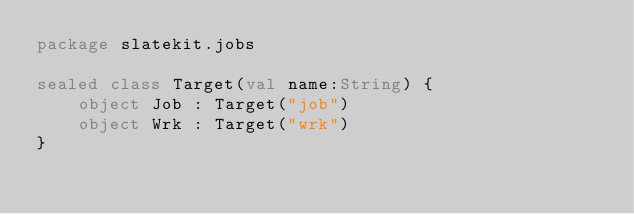<code> <loc_0><loc_0><loc_500><loc_500><_Kotlin_>package slatekit.jobs

sealed class Target(val name:String) {
    object Job : Target("job")
    object Wrk : Target("wrk")
}
</code> 